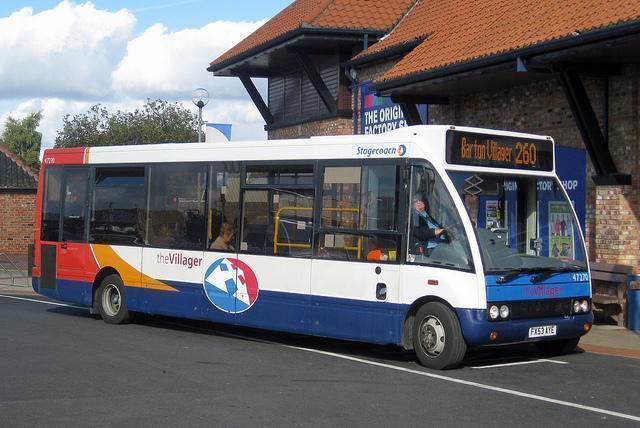Where does this bus stop here?
Choose the correct response, then elucidate: 'Answer: answer
Rationale: rationale.'
Options: School, crosswalk, outlet mall, church. Answer: outlet mall.
Rationale: The bus stops next to a building.  the building has a large sign that says it contains factory stores.  factory stores together in one location are an outlet mall. 